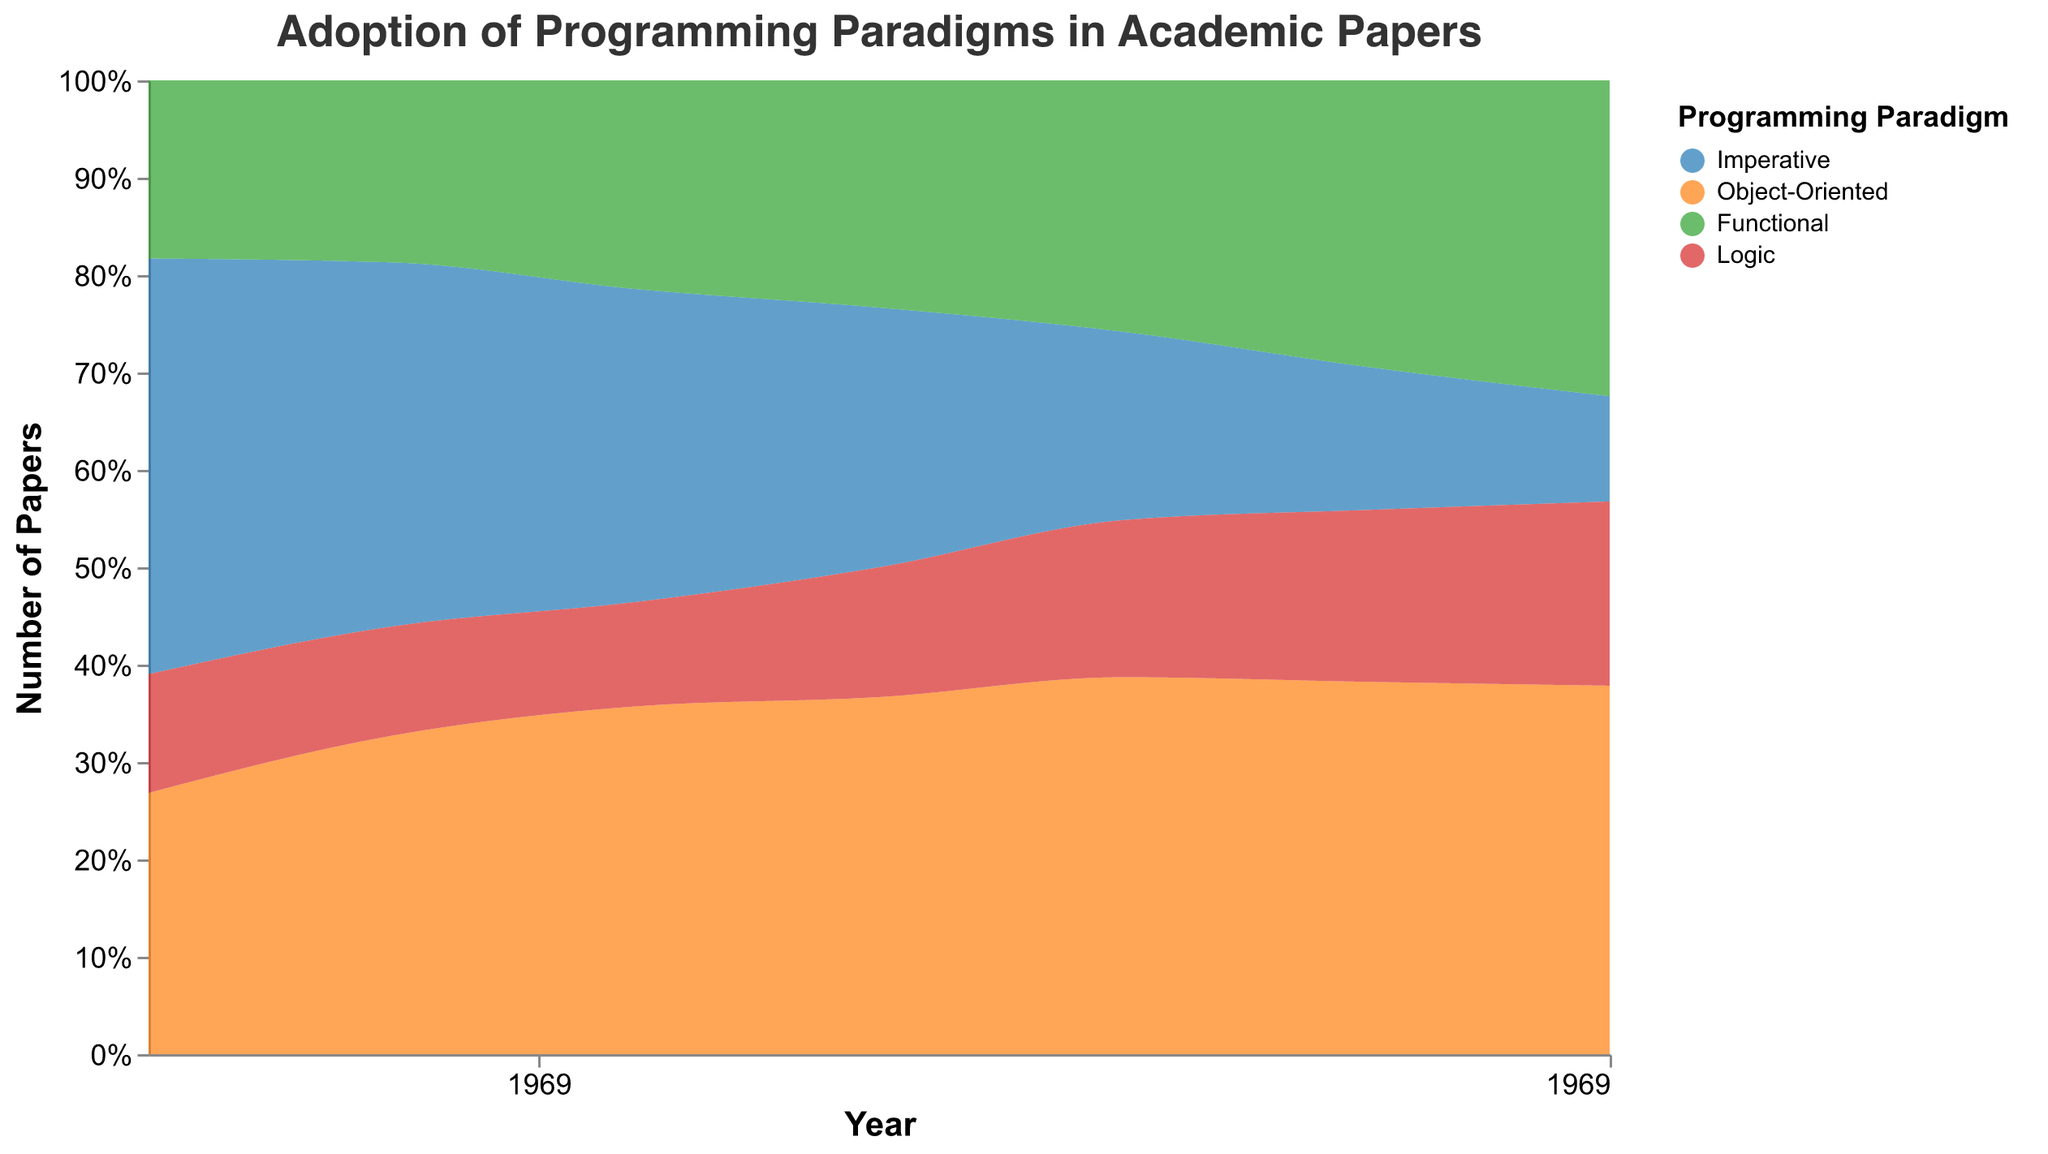What is the title of the figure? The title is displayed at the top of the figure. It reads "Adoption of Programming Paradigms in Academic Papers".
Answer: Adoption of Programming Paradigms in Academic Papers How many programming paradigms are shown in the plot? The legend on the right side of the plot shows four different paradigms: Imperative, Object-Oriented, Functional, and Logic.
Answer: Four Which color represents the Functional programming paradigm? The legend indicates that the Functional programming paradigm is represented by green.
Answer: Green What is the y-axis title? The y-axis title, located next to the y-axis, reads "Number of Papers".
Answer: Number of Papers How many years are displayed on the x-axis? The x-axis displays years at regular intervals. Counting them, we see six different years: 1990, 1995, 2000, 2005, 2010, and 2020.
Answer: Six What is the total number of papers for Functional paradigm in 2000 and 2010? Reviewing the figure, the number of papers for Functional paradigm in 2000 is 30, and in 2010 is 40. Adding them gives 30 + 40 = 70.
Answer: 70 What is the combined number of papers published in 2015 for Imperative and Object-Oriented paradigms? The graph shows 25 papers for Imperative and 65 papers for Object-Oriented in 2015, summing these gives 25 + 65 = 90.
Answer: 90 By how much did the number of papers on Object-Oriented programming increase from 1990 to 2020? In 1990, the number of Object-Oriented papers was 22, and by 2020 it had increased to 70. The difference is 70 - 22 = 48.
Answer: 48 What is the average number of papers for Logic paradigm in 1995, 2005, and 2020? The number of Logic papers in these years are 12, 20, and 35 respectively. Their sum is 12 + 20 + 35 = 67, and the average is 67 / 3 = 22.33.
Answer: 22.33 Which programming paradigm had the highest number of papers in 2020? Observing the plot for the year 2020, the Object-Oriented programming paradigm has the highest stack, representing 70 papers.
Answer: Object-Oriented Which paradigm shows a consistent increase in the number of papers from 1990 to 2020? The Object-Oriented paradigm consistently increases from 22 papers in 1990 to 70 papers in 2020, as shown by the steadily rising area for this paradigm.
Answer: Object-Oriented Did the number of papers for the Imperative paradigm increase or decrease from 2000 to 2020? The plot shows that the number of Imperative papers decreased from 45 in 2000 to 20 in 2020.
Answer: Decrease Which paradigm had fewer papers in 2000, Logic or Functional? In 2000, the number of papers for Logic is 15 and for Functional is 30; the Logic paradigm had fewer papers.
Answer: Logic What proportion of papers in 2015 were about the Object-Oriented paradigm? In 2015, the total number of papers across all paradigms can be calculated from the plot, and specifically, 65 were Object-Oriented. We need to look at the others and sum accordingly for a percentage, which shows a dominant proportion. (65 Object-Oriented, Total: 25 + 65 + 50 + 30 = 170, proportion: 65/170 = 0.38 or 38%).
Answer: 38% From the density plot, which paradigm saw the most notable decline in the number of papers over time? The density plot shows a significant decline for the Imperative paradigm, which starts from 40-45 across early years to just 20 by 2020.
Answer: Imperative 